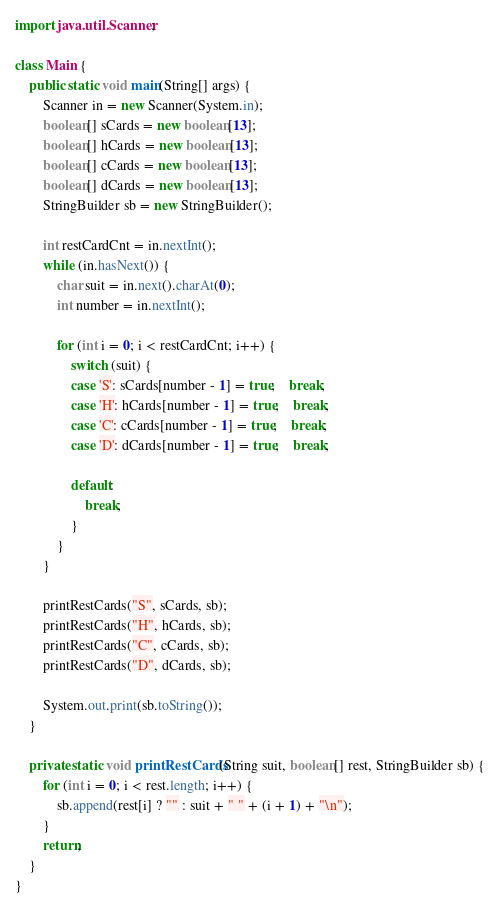Convert code to text. <code><loc_0><loc_0><loc_500><loc_500><_Java_>import java.util.Scanner;

class Main {
    public static void main(String[] args) {
        Scanner in = new Scanner(System.in);
        boolean[] sCards = new boolean[13];
        boolean[] hCards = new boolean[13];
        boolean[] cCards = new boolean[13];
        boolean[] dCards = new boolean[13];
        StringBuilder sb = new StringBuilder();

        int restCardCnt = in.nextInt();
        while (in.hasNext()) {
            char suit = in.next().charAt(0);
            int number = in.nextInt();

            for (int i = 0; i < restCardCnt; i++) {
                switch (suit) {
                case 'S': sCards[number - 1] = true;    break;
                case 'H': hCards[number - 1] = true;    break;
                case 'C': cCards[number - 1] = true;    break;
                case 'D': dCards[number - 1] = true;    break;

                default:
                    break;
                }
            }
        }

        printRestCards("S", sCards, sb);
        printRestCards("H", hCards, sb);
        printRestCards("C", cCards, sb);
        printRestCards("D", dCards, sb);

        System.out.print(sb.toString());
    }

    private static void printRestCards(String suit, boolean[] rest, StringBuilder sb) {
        for (int i = 0; i < rest.length; i++) {
            sb.append(rest[i] ? "" : suit + " " + (i + 1) + "\n");
        }
        return;
    }
}</code> 